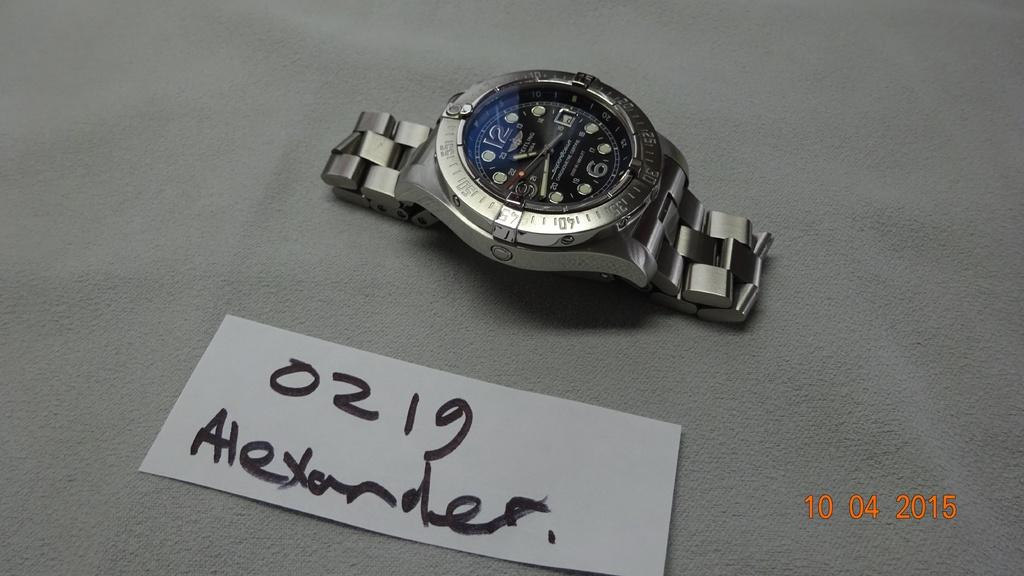<image>
Write a terse but informative summary of the picture. A watch is sitting near a small card with the name Alexander on it. 